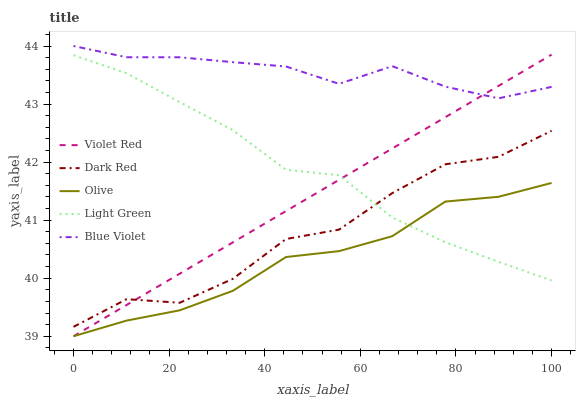Does Dark Red have the minimum area under the curve?
Answer yes or no. No. Does Dark Red have the maximum area under the curve?
Answer yes or no. No. Is Dark Red the smoothest?
Answer yes or no. No. Is Violet Red the roughest?
Answer yes or no. No. Does Dark Red have the lowest value?
Answer yes or no. No. Does Dark Red have the highest value?
Answer yes or no. No. Is Light Green less than Blue Violet?
Answer yes or no. Yes. Is Blue Violet greater than Olive?
Answer yes or no. Yes. Does Light Green intersect Blue Violet?
Answer yes or no. No. 